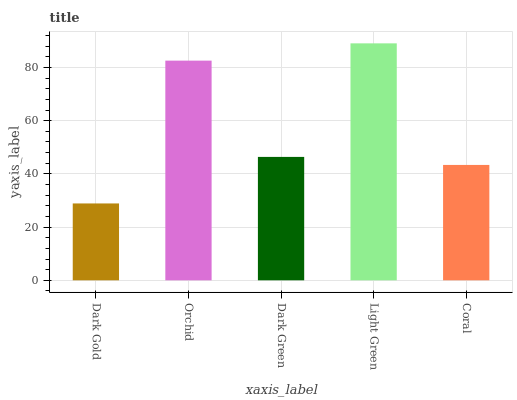Is Dark Gold the minimum?
Answer yes or no. Yes. Is Light Green the maximum?
Answer yes or no. Yes. Is Orchid the minimum?
Answer yes or no. No. Is Orchid the maximum?
Answer yes or no. No. Is Orchid greater than Dark Gold?
Answer yes or no. Yes. Is Dark Gold less than Orchid?
Answer yes or no. Yes. Is Dark Gold greater than Orchid?
Answer yes or no. No. Is Orchid less than Dark Gold?
Answer yes or no. No. Is Dark Green the high median?
Answer yes or no. Yes. Is Dark Green the low median?
Answer yes or no. Yes. Is Dark Gold the high median?
Answer yes or no. No. Is Dark Gold the low median?
Answer yes or no. No. 